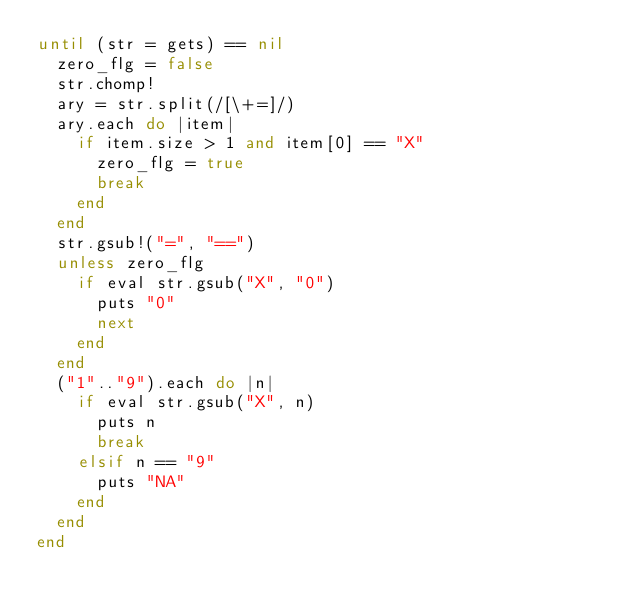<code> <loc_0><loc_0><loc_500><loc_500><_Ruby_>until (str = gets) == nil
  zero_flg = false
  str.chomp!
  ary = str.split(/[\+=]/)
  ary.each do |item|
    if item.size > 1 and item[0] == "X"
      zero_flg = true
      break
    end
  end
  str.gsub!("=", "==")
  unless zero_flg
    if eval str.gsub("X", "0")
      puts "0"
      next
    end
  end
  ("1".."9").each do |n|
    if eval str.gsub("X", n)
      puts n
      break
    elsif n == "9"
      puts "NA"
    end
  end
end</code> 